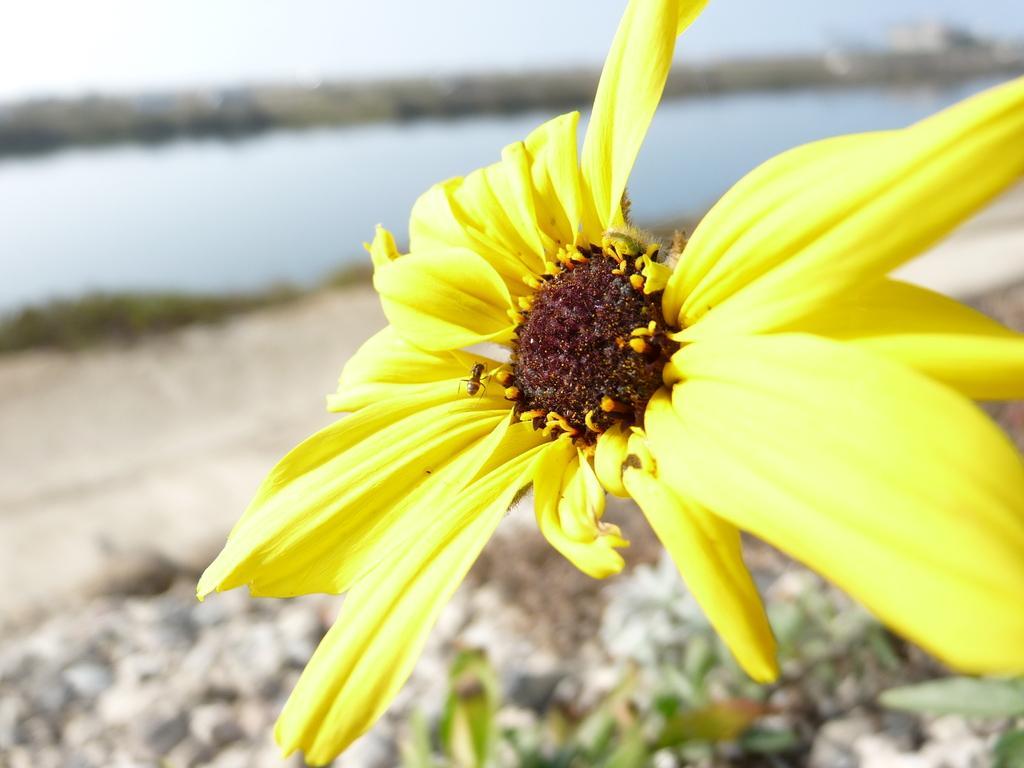Could you give a brief overview of what you see in this image? In this picture I can see a flower, there is water, and in the background there is the sky. 